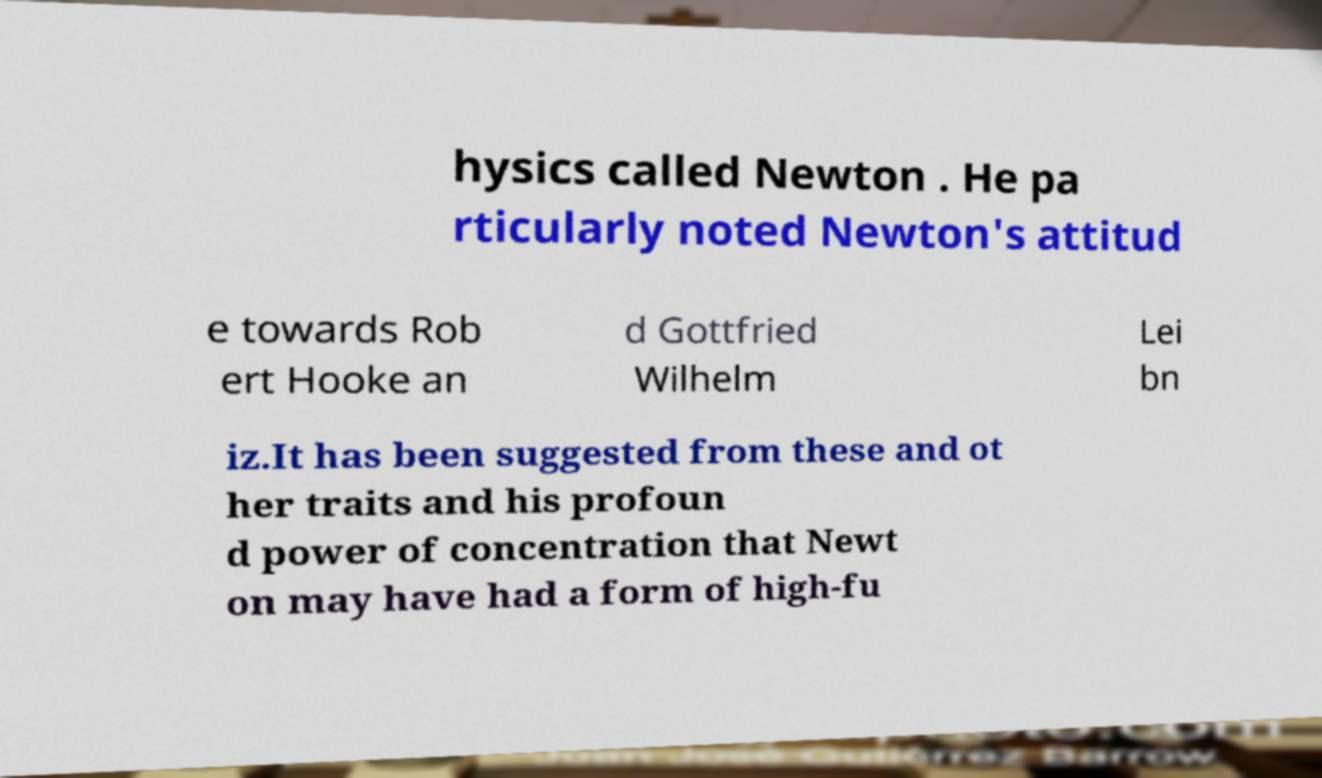Can you read and provide the text displayed in the image?This photo seems to have some interesting text. Can you extract and type it out for me? hysics called Newton . He pa rticularly noted Newton's attitud e towards Rob ert Hooke an d Gottfried Wilhelm Lei bn iz.It has been suggested from these and ot her traits and his profoun d power of concentration that Newt on may have had a form of high-fu 